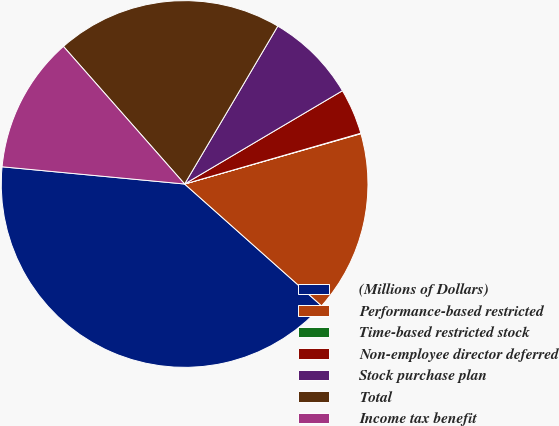Convert chart to OTSL. <chart><loc_0><loc_0><loc_500><loc_500><pie_chart><fcel>(Millions of Dollars)<fcel>Performance-based restricted<fcel>Time-based restricted stock<fcel>Non-employee director deferred<fcel>Stock purchase plan<fcel>Total<fcel>Income tax benefit<nl><fcel>39.93%<fcel>16.0%<fcel>0.04%<fcel>4.03%<fcel>8.02%<fcel>19.98%<fcel>12.01%<nl></chart> 